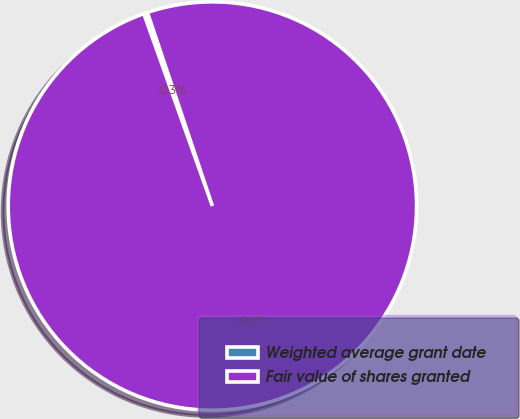Convert chart. <chart><loc_0><loc_0><loc_500><loc_500><pie_chart><fcel>Weighted average grant date<fcel>Fair value of shares granted<nl><fcel>0.3%<fcel>99.7%<nl></chart> 